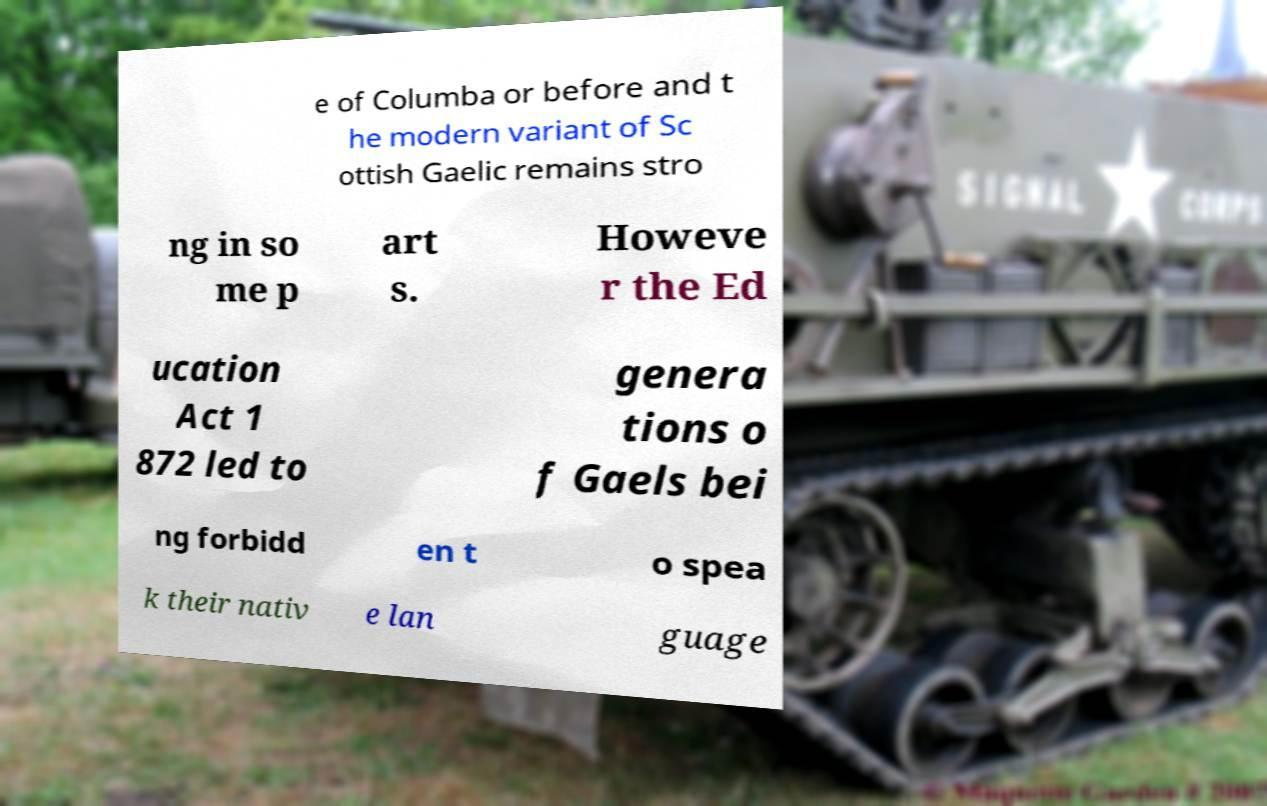Can you accurately transcribe the text from the provided image for me? e of Columba or before and t he modern variant of Sc ottish Gaelic remains stro ng in so me p art s. Howeve r the Ed ucation Act 1 872 led to genera tions o f Gaels bei ng forbidd en t o spea k their nativ e lan guage 